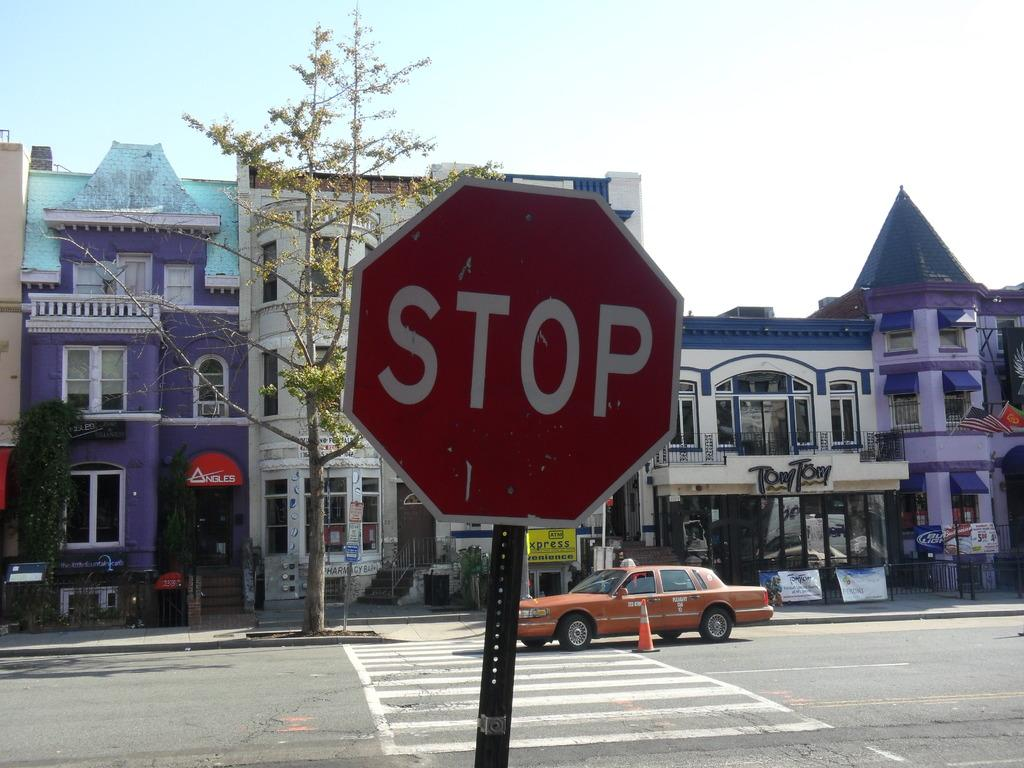Provide a one-sentence caption for the provided image. A stop sign stands in front of a high building with a car park in front. 